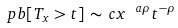<formula> <loc_0><loc_0><loc_500><loc_500>\ p b [ T _ { x } > t ] \, \sim \, c x ^ { \ a \rho } t ^ { - \rho }</formula> 